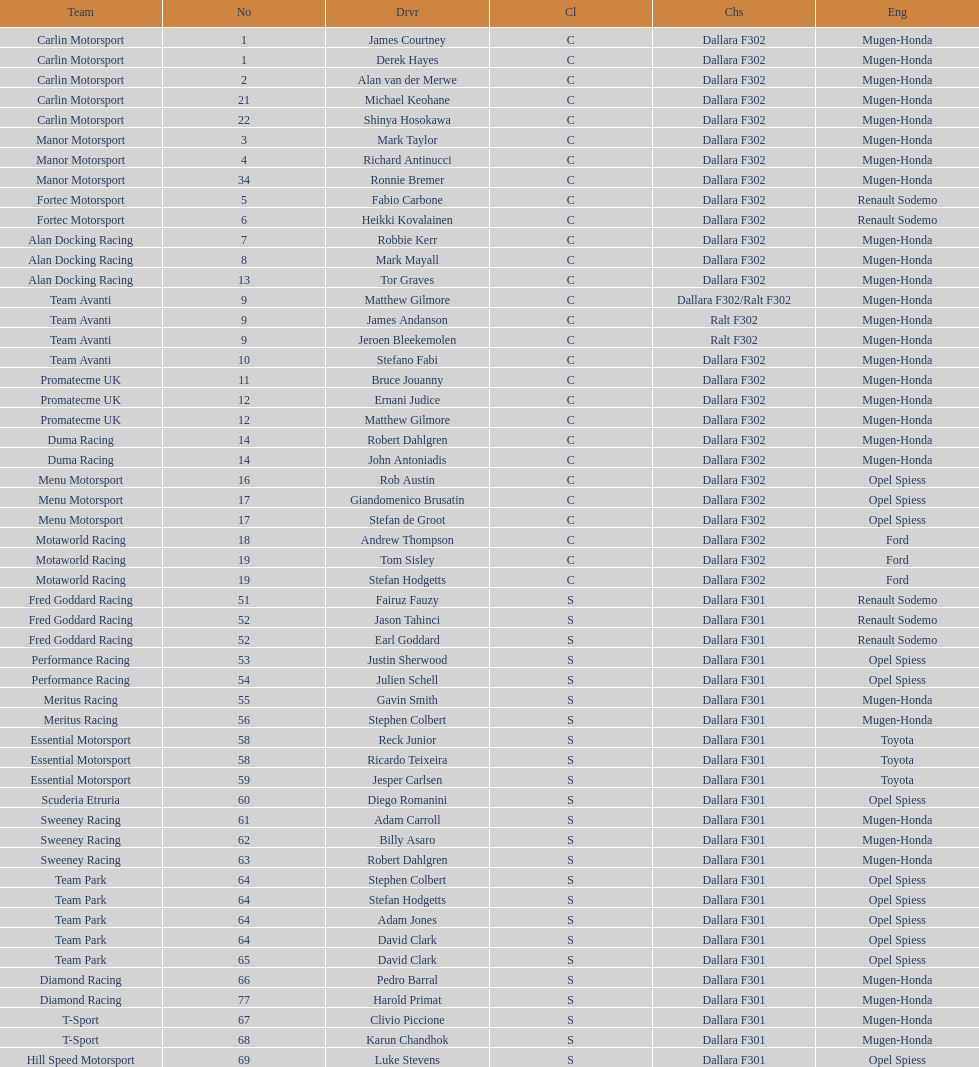How many teams had at least two drivers this season? 17. Give me the full table as a dictionary. {'header': ['Team', 'No', 'Drvr', 'Cl', 'Chs', 'Eng'], 'rows': [['Carlin Motorsport', '1', 'James Courtney', 'C', 'Dallara F302', 'Mugen-Honda'], ['Carlin Motorsport', '1', 'Derek Hayes', 'C', 'Dallara F302', 'Mugen-Honda'], ['Carlin Motorsport', '2', 'Alan van der Merwe', 'C', 'Dallara F302', 'Mugen-Honda'], ['Carlin Motorsport', '21', 'Michael Keohane', 'C', 'Dallara F302', 'Mugen-Honda'], ['Carlin Motorsport', '22', 'Shinya Hosokawa', 'C', 'Dallara F302', 'Mugen-Honda'], ['Manor Motorsport', '3', 'Mark Taylor', 'C', 'Dallara F302', 'Mugen-Honda'], ['Manor Motorsport', '4', 'Richard Antinucci', 'C', 'Dallara F302', 'Mugen-Honda'], ['Manor Motorsport', '34', 'Ronnie Bremer', 'C', 'Dallara F302', 'Mugen-Honda'], ['Fortec Motorsport', '5', 'Fabio Carbone', 'C', 'Dallara F302', 'Renault Sodemo'], ['Fortec Motorsport', '6', 'Heikki Kovalainen', 'C', 'Dallara F302', 'Renault Sodemo'], ['Alan Docking Racing', '7', 'Robbie Kerr', 'C', 'Dallara F302', 'Mugen-Honda'], ['Alan Docking Racing', '8', 'Mark Mayall', 'C', 'Dallara F302', 'Mugen-Honda'], ['Alan Docking Racing', '13', 'Tor Graves', 'C', 'Dallara F302', 'Mugen-Honda'], ['Team Avanti', '9', 'Matthew Gilmore', 'C', 'Dallara F302/Ralt F302', 'Mugen-Honda'], ['Team Avanti', '9', 'James Andanson', 'C', 'Ralt F302', 'Mugen-Honda'], ['Team Avanti', '9', 'Jeroen Bleekemolen', 'C', 'Ralt F302', 'Mugen-Honda'], ['Team Avanti', '10', 'Stefano Fabi', 'C', 'Dallara F302', 'Mugen-Honda'], ['Promatecme UK', '11', 'Bruce Jouanny', 'C', 'Dallara F302', 'Mugen-Honda'], ['Promatecme UK', '12', 'Ernani Judice', 'C', 'Dallara F302', 'Mugen-Honda'], ['Promatecme UK', '12', 'Matthew Gilmore', 'C', 'Dallara F302', 'Mugen-Honda'], ['Duma Racing', '14', 'Robert Dahlgren', 'C', 'Dallara F302', 'Mugen-Honda'], ['Duma Racing', '14', 'John Antoniadis', 'C', 'Dallara F302', 'Mugen-Honda'], ['Menu Motorsport', '16', 'Rob Austin', 'C', 'Dallara F302', 'Opel Spiess'], ['Menu Motorsport', '17', 'Giandomenico Brusatin', 'C', 'Dallara F302', 'Opel Spiess'], ['Menu Motorsport', '17', 'Stefan de Groot', 'C', 'Dallara F302', 'Opel Spiess'], ['Motaworld Racing', '18', 'Andrew Thompson', 'C', 'Dallara F302', 'Ford'], ['Motaworld Racing', '19', 'Tom Sisley', 'C', 'Dallara F302', 'Ford'], ['Motaworld Racing', '19', 'Stefan Hodgetts', 'C', 'Dallara F302', 'Ford'], ['Fred Goddard Racing', '51', 'Fairuz Fauzy', 'S', 'Dallara F301', 'Renault Sodemo'], ['Fred Goddard Racing', '52', 'Jason Tahinci', 'S', 'Dallara F301', 'Renault Sodemo'], ['Fred Goddard Racing', '52', 'Earl Goddard', 'S', 'Dallara F301', 'Renault Sodemo'], ['Performance Racing', '53', 'Justin Sherwood', 'S', 'Dallara F301', 'Opel Spiess'], ['Performance Racing', '54', 'Julien Schell', 'S', 'Dallara F301', 'Opel Spiess'], ['Meritus Racing', '55', 'Gavin Smith', 'S', 'Dallara F301', 'Mugen-Honda'], ['Meritus Racing', '56', 'Stephen Colbert', 'S', 'Dallara F301', 'Mugen-Honda'], ['Essential Motorsport', '58', 'Reck Junior', 'S', 'Dallara F301', 'Toyota'], ['Essential Motorsport', '58', 'Ricardo Teixeira', 'S', 'Dallara F301', 'Toyota'], ['Essential Motorsport', '59', 'Jesper Carlsen', 'S', 'Dallara F301', 'Toyota'], ['Scuderia Etruria', '60', 'Diego Romanini', 'S', 'Dallara F301', 'Opel Spiess'], ['Sweeney Racing', '61', 'Adam Carroll', 'S', 'Dallara F301', 'Mugen-Honda'], ['Sweeney Racing', '62', 'Billy Asaro', 'S', 'Dallara F301', 'Mugen-Honda'], ['Sweeney Racing', '63', 'Robert Dahlgren', 'S', 'Dallara F301', 'Mugen-Honda'], ['Team Park', '64', 'Stephen Colbert', 'S', 'Dallara F301', 'Opel Spiess'], ['Team Park', '64', 'Stefan Hodgetts', 'S', 'Dallara F301', 'Opel Spiess'], ['Team Park', '64', 'Adam Jones', 'S', 'Dallara F301', 'Opel Spiess'], ['Team Park', '64', 'David Clark', 'S', 'Dallara F301', 'Opel Spiess'], ['Team Park', '65', 'David Clark', 'S', 'Dallara F301', 'Opel Spiess'], ['Diamond Racing', '66', 'Pedro Barral', 'S', 'Dallara F301', 'Mugen-Honda'], ['Diamond Racing', '77', 'Harold Primat', 'S', 'Dallara F301', 'Mugen-Honda'], ['T-Sport', '67', 'Clivio Piccione', 'S', 'Dallara F301', 'Mugen-Honda'], ['T-Sport', '68', 'Karun Chandhok', 'S', 'Dallara F301', 'Mugen-Honda'], ['Hill Speed Motorsport', '69', 'Luke Stevens', 'S', 'Dallara F301', 'Opel Spiess']]} 